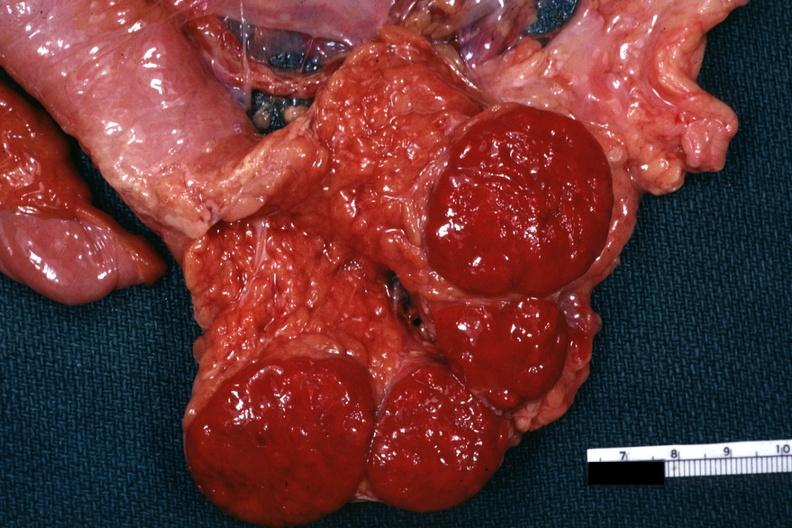s atrophy secondary to pituitectomy present?
Answer the question using a single word or phrase. No 